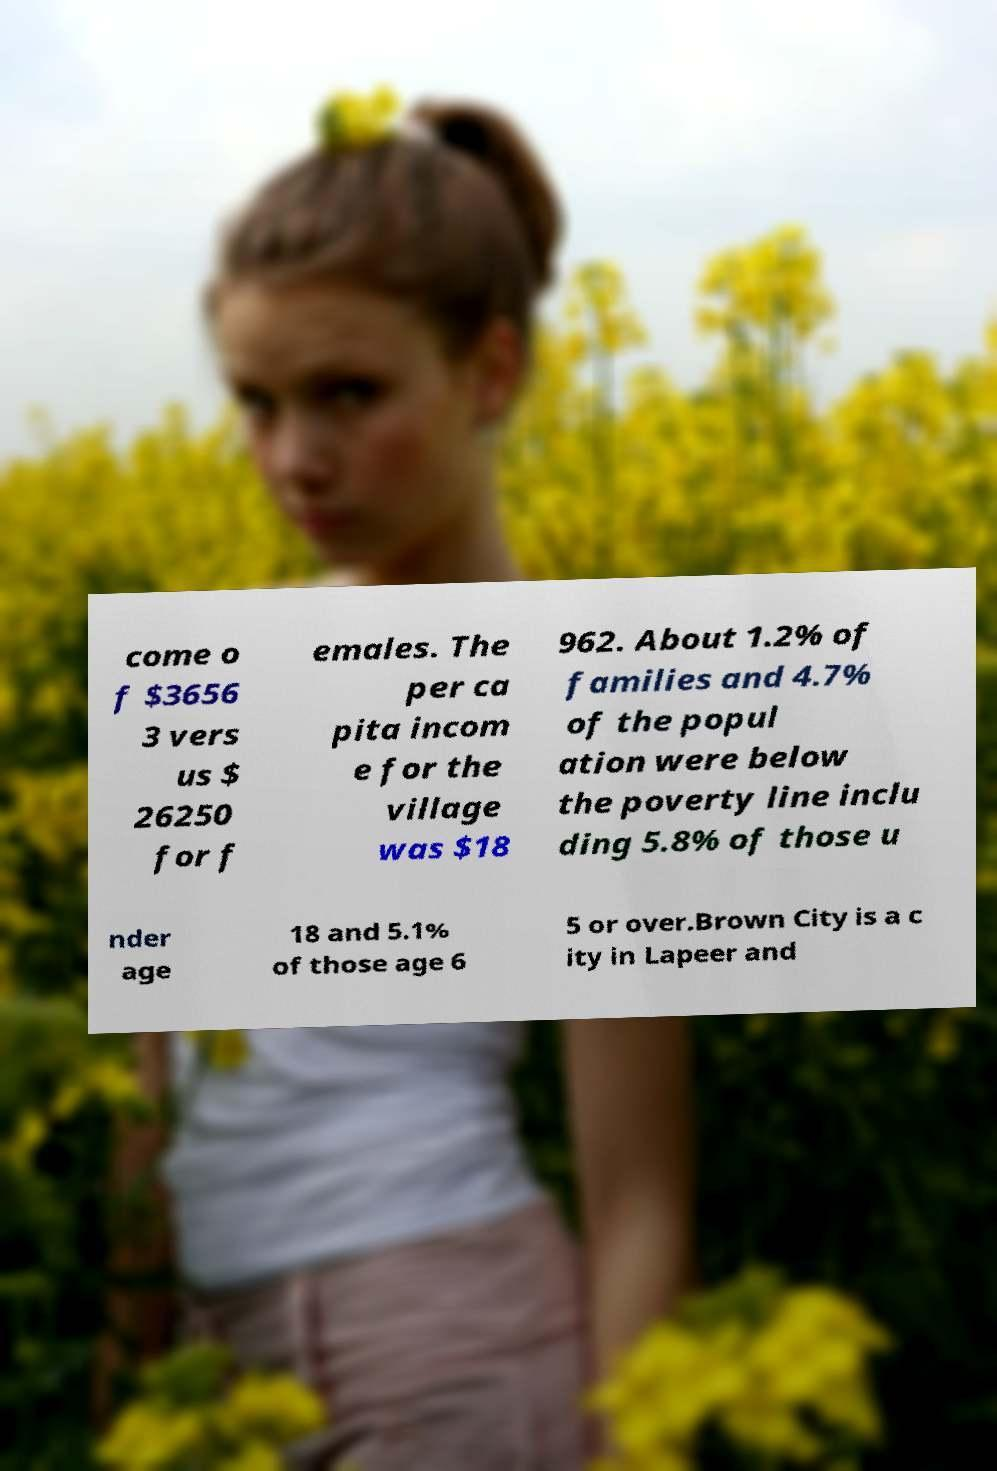Please identify and transcribe the text found in this image. come o f $3656 3 vers us $ 26250 for f emales. The per ca pita incom e for the village was $18 962. About 1.2% of families and 4.7% of the popul ation were below the poverty line inclu ding 5.8% of those u nder age 18 and 5.1% of those age 6 5 or over.Brown City is a c ity in Lapeer and 